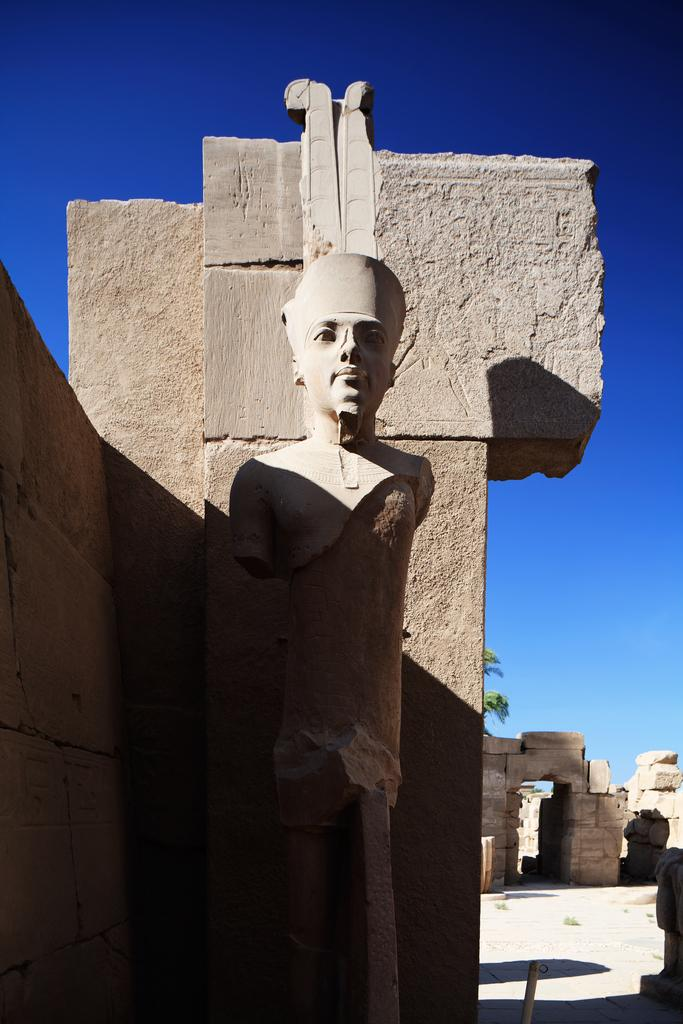What is the main subject in the image? There is a statue in the image. What can be seen in the background of the image? There is a wall and the sky visible in the background of the image. How many clocks are hanging on the wall in the image? There are no clocks visible in the image; only a statue, a wall, and the sky are present. 